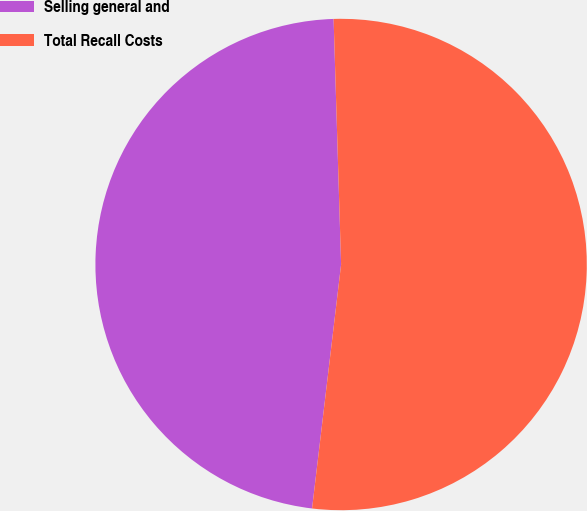<chart> <loc_0><loc_0><loc_500><loc_500><pie_chart><fcel>Selling general and<fcel>Total Recall Costs<nl><fcel>47.63%<fcel>52.37%<nl></chart> 